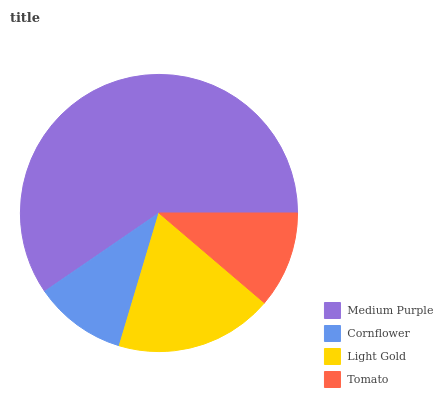Is Cornflower the minimum?
Answer yes or no. Yes. Is Medium Purple the maximum?
Answer yes or no. Yes. Is Light Gold the minimum?
Answer yes or no. No. Is Light Gold the maximum?
Answer yes or no. No. Is Light Gold greater than Cornflower?
Answer yes or no. Yes. Is Cornflower less than Light Gold?
Answer yes or no. Yes. Is Cornflower greater than Light Gold?
Answer yes or no. No. Is Light Gold less than Cornflower?
Answer yes or no. No. Is Light Gold the high median?
Answer yes or no. Yes. Is Tomato the low median?
Answer yes or no. Yes. Is Medium Purple the high median?
Answer yes or no. No. Is Medium Purple the low median?
Answer yes or no. No. 